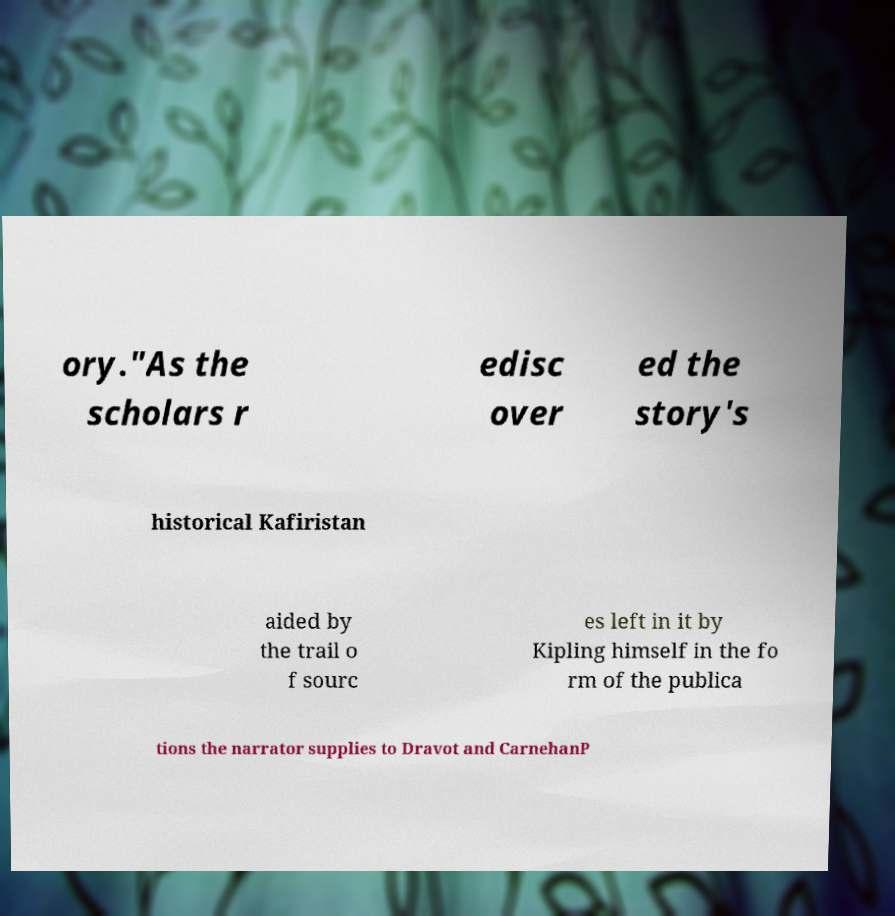Can you read and provide the text displayed in the image?This photo seems to have some interesting text. Can you extract and type it out for me? ory."As the scholars r edisc over ed the story's historical Kafiristan aided by the trail o f sourc es left in it by Kipling himself in the fo rm of the publica tions the narrator supplies to Dravot and CarnehanP 